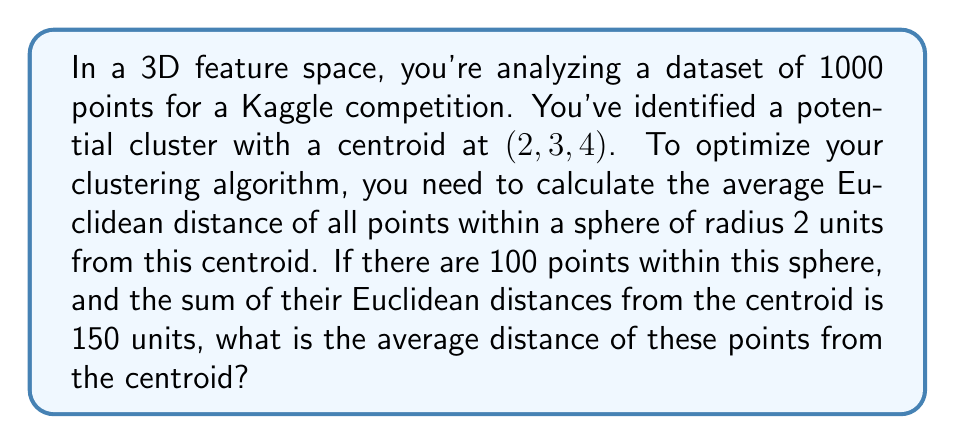Provide a solution to this math problem. To solve this problem, we'll follow these steps:

1) Recall the formula for the average (mean):
   $$ \text{Average} = \frac{\text{Sum of values}}{\text{Number of values}} $$

2) In this case:
   - Sum of Euclidean distances = 150 units
   - Number of points = 100

3) Plugging these values into the formula:
   $$ \text{Average distance} = \frac{150 \text{ units}}{100} $$

4) Simplify:
   $$ \text{Average distance} = 1.5 \text{ units} $$

This result gives us the average Euclidean distance of the points within the sphere from the centroid. This information can be crucial for feature engineering and optimizing clustering algorithms, as it provides insight into the density and distribution of points within the identified cluster.
Answer: 1.5 units 